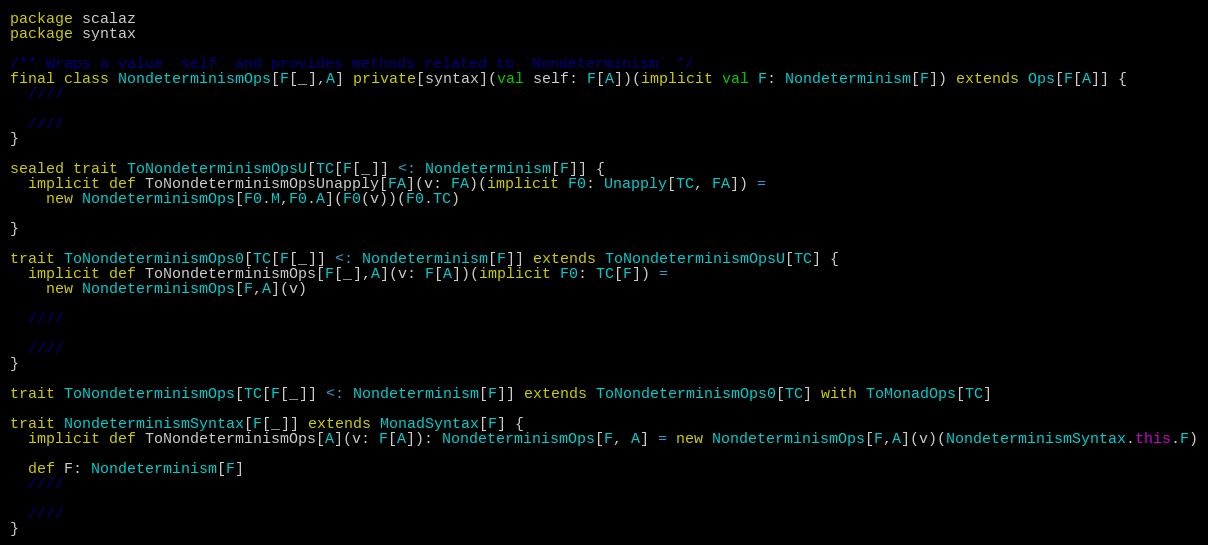<code> <loc_0><loc_0><loc_500><loc_500><_Scala_>package scalaz
package syntax

/** Wraps a value `self` and provides methods related to `Nondeterminism` */
final class NondeterminismOps[F[_],A] private[syntax](val self: F[A])(implicit val F: Nondeterminism[F]) extends Ops[F[A]] {
  ////

  ////
}

sealed trait ToNondeterminismOpsU[TC[F[_]] <: Nondeterminism[F]] {
  implicit def ToNondeterminismOpsUnapply[FA](v: FA)(implicit F0: Unapply[TC, FA]) =
    new NondeterminismOps[F0.M,F0.A](F0(v))(F0.TC)

}

trait ToNondeterminismOps0[TC[F[_]] <: Nondeterminism[F]] extends ToNondeterminismOpsU[TC] {
  implicit def ToNondeterminismOps[F[_],A](v: F[A])(implicit F0: TC[F]) =
    new NondeterminismOps[F,A](v)

  ////

  ////
}

trait ToNondeterminismOps[TC[F[_]] <: Nondeterminism[F]] extends ToNondeterminismOps0[TC] with ToMonadOps[TC]

trait NondeterminismSyntax[F[_]] extends MonadSyntax[F] {
  implicit def ToNondeterminismOps[A](v: F[A]): NondeterminismOps[F, A] = new NondeterminismOps[F,A](v)(NondeterminismSyntax.this.F)

  def F: Nondeterminism[F]
  ////

  ////
}
</code> 